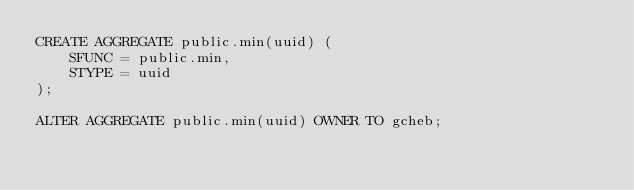Convert code to text. <code><loc_0><loc_0><loc_500><loc_500><_SQL_>CREATE AGGREGATE public.min(uuid) (
	SFUNC = public.min,
	STYPE = uuid
);

ALTER AGGREGATE public.min(uuid) OWNER TO gcheb;
</code> 